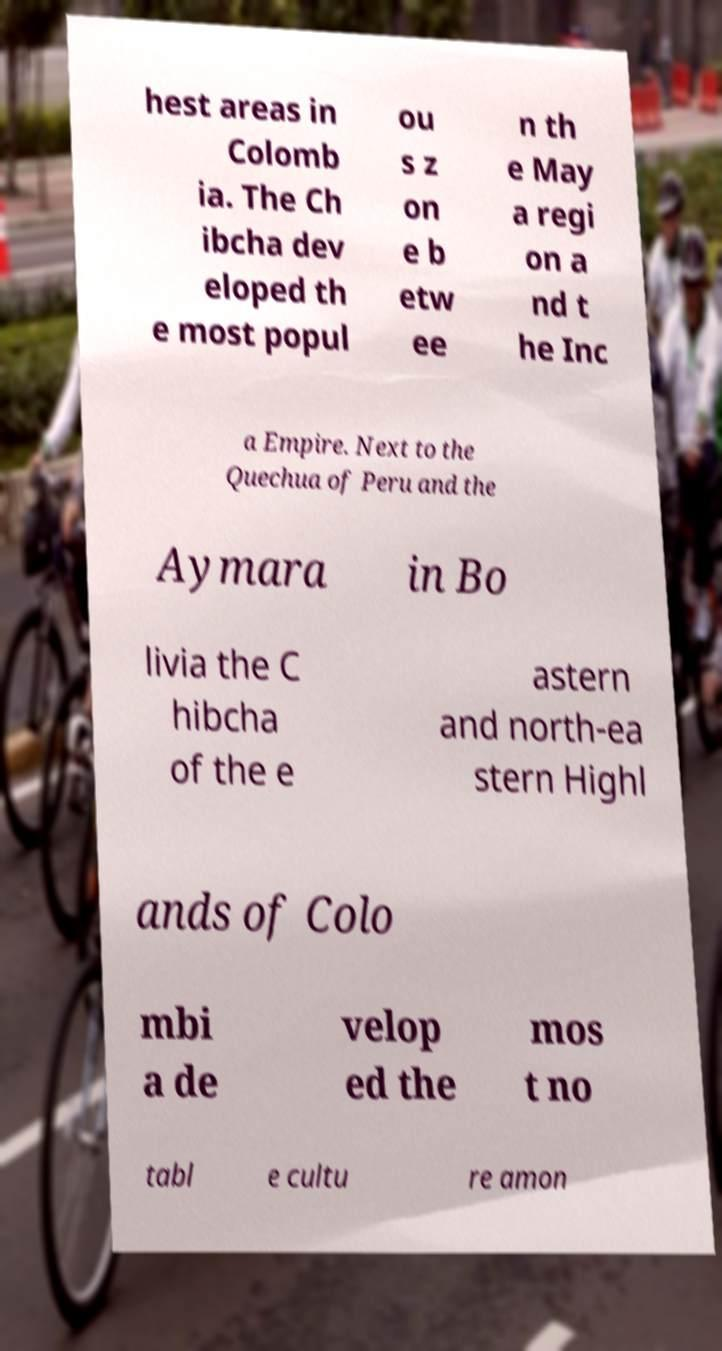Can you accurately transcribe the text from the provided image for me? hest areas in Colomb ia. The Ch ibcha dev eloped th e most popul ou s z on e b etw ee n th e May a regi on a nd t he Inc a Empire. Next to the Quechua of Peru and the Aymara in Bo livia the C hibcha of the e astern and north-ea stern Highl ands of Colo mbi a de velop ed the mos t no tabl e cultu re amon 